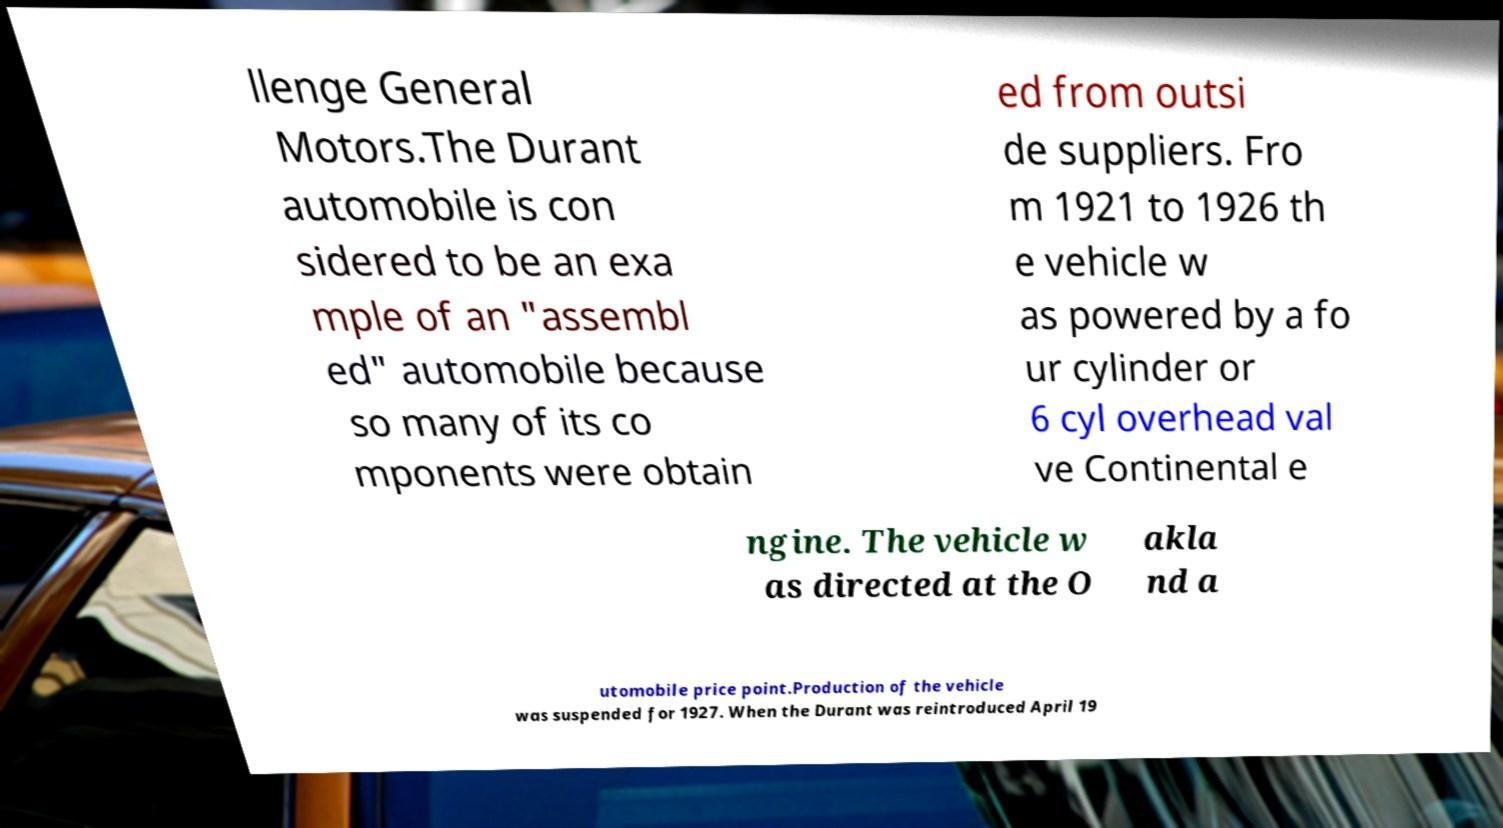Can you accurately transcribe the text from the provided image for me? llenge General Motors.The Durant automobile is con sidered to be an exa mple of an "assembl ed" automobile because so many of its co mponents were obtain ed from outsi de suppliers. Fro m 1921 to 1926 th e vehicle w as powered by a fo ur cylinder or 6 cyl overhead val ve Continental e ngine. The vehicle w as directed at the O akla nd a utomobile price point.Production of the vehicle was suspended for 1927. When the Durant was reintroduced April 19 